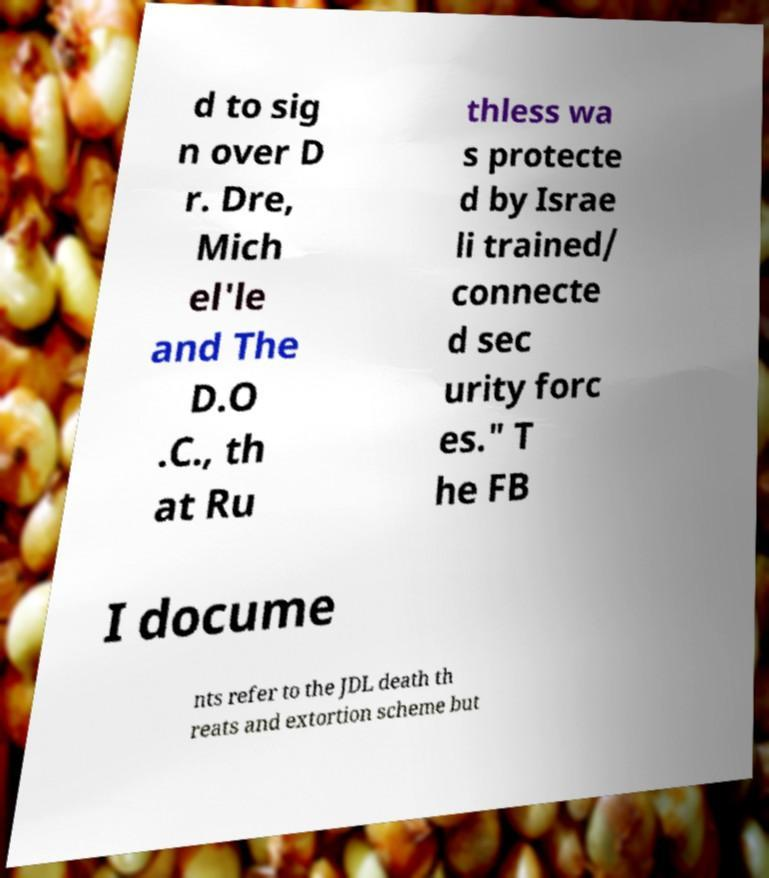There's text embedded in this image that I need extracted. Can you transcribe it verbatim? d to sig n over D r. Dre, Mich el'le and The D.O .C., th at Ru thless wa s protecte d by Israe li trained/ connecte d sec urity forc es." T he FB I docume nts refer to the JDL death th reats and extortion scheme but 